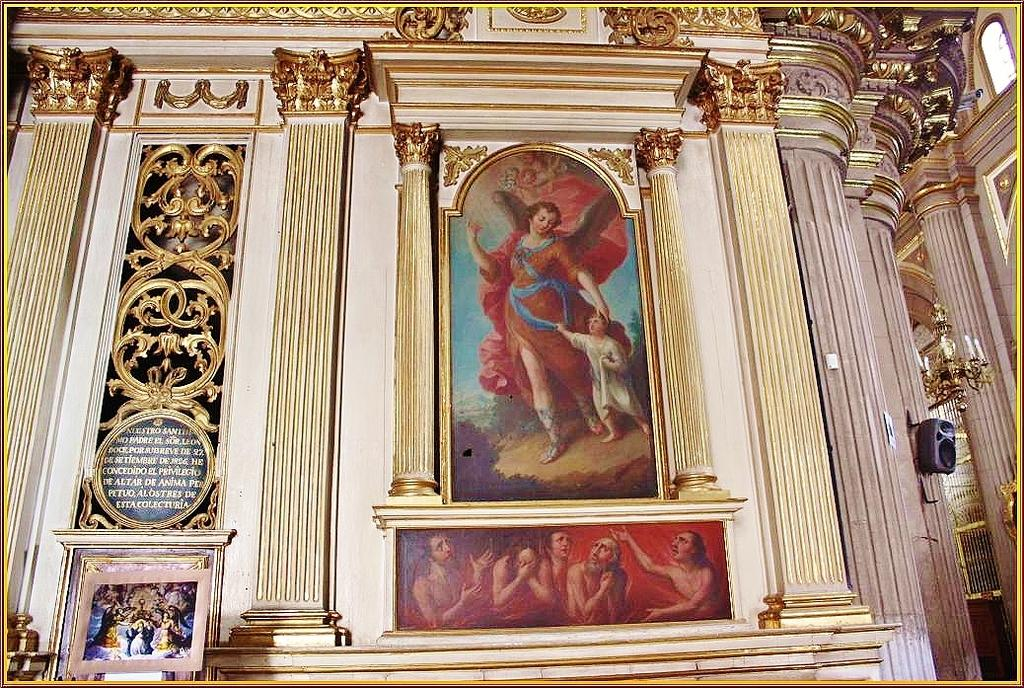What can be seen on the wall in the image? There are photo frames on the wall in the image. What type of visual elements are present in the image? There are designs visible in the image. Are there any words or letters in the image? Yes, there is text present in the image. What else can be observed in the image besides the photo frames, designs, and text? There are objects visible in the image. Can you tell me how many ducks are in the crib in the image? There are no ducks or cribs present in the image. 